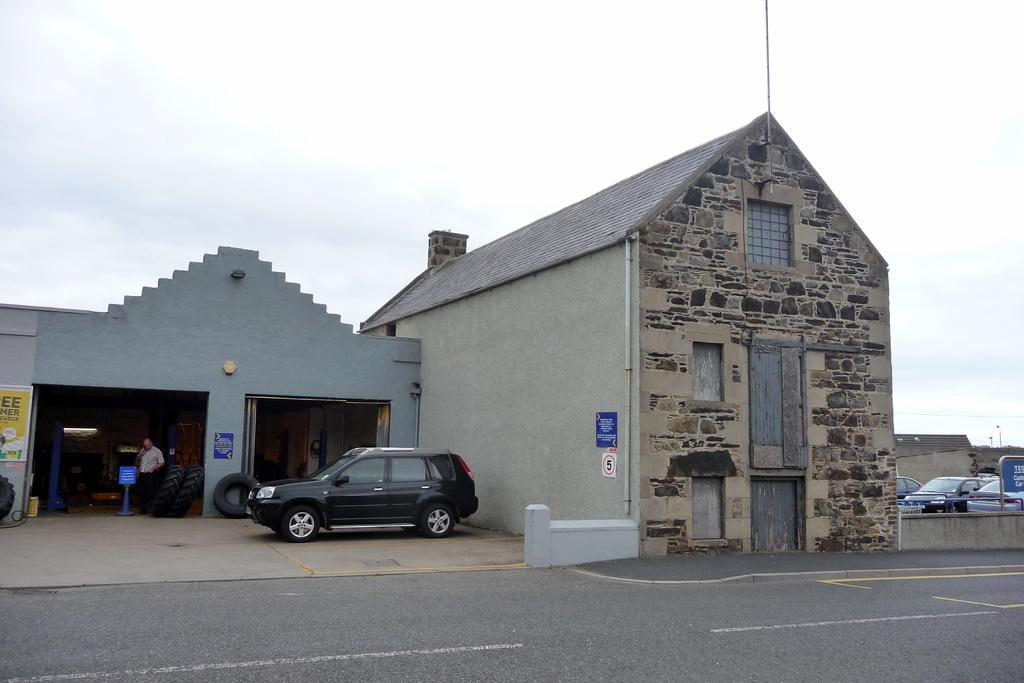What type of structures can be seen in the image? There are buildings in the image. What mode of transportation can be seen in the image? Motor vehicles are present in the image. What part of a vehicle is visible in the image? There are tyres in the image. What type of signage is visible in the image? Information boards are visible in the image. What type of vertical structures are present in the image? Poles are present in the image. What type of surface can be seen in the image? There is a road in the image. What part of the natural environment is visible in the image? The sky is visible in the image. What type of letters can be seen on the hospital in the image? There is no hospital present in the image, so it is not possible to determine what type of letters might be on it. 